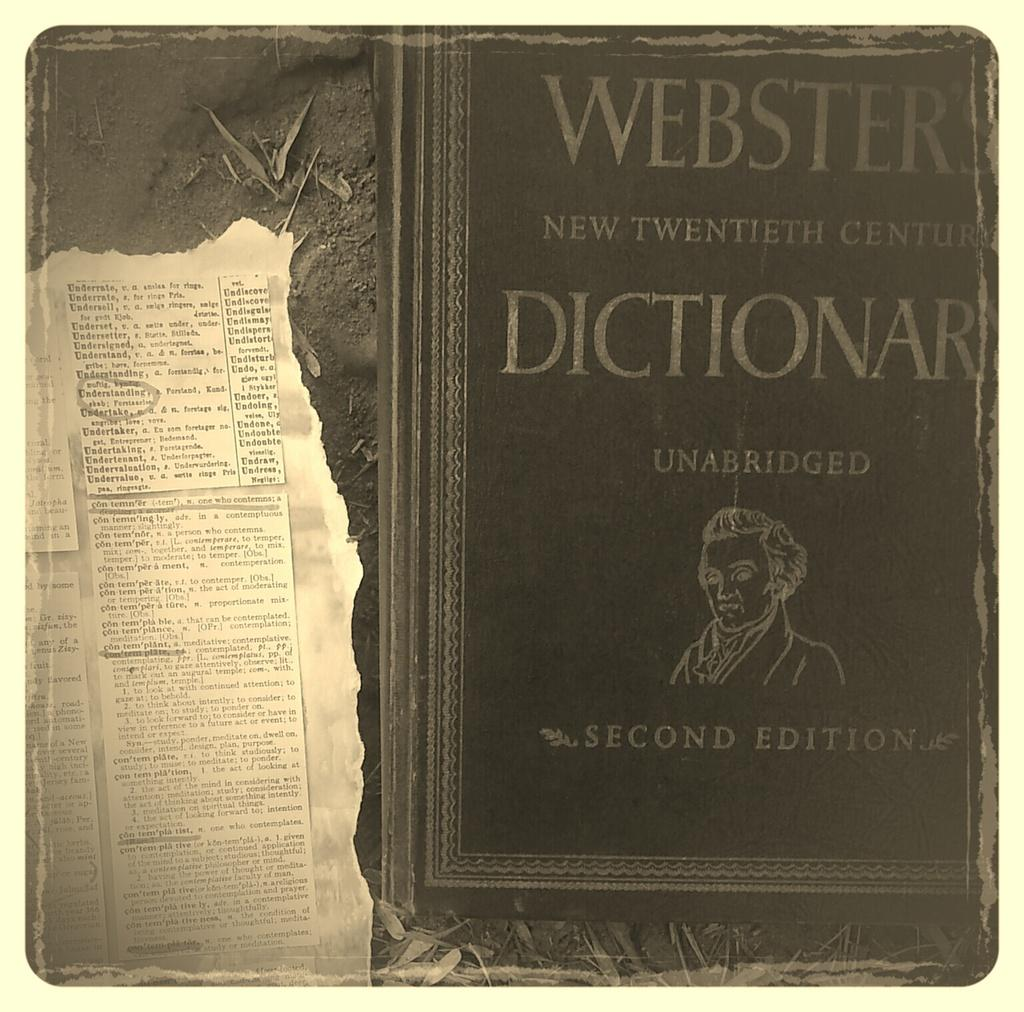Provide a one-sentence caption for the provided image. A page was torn out of the old dictionary. 